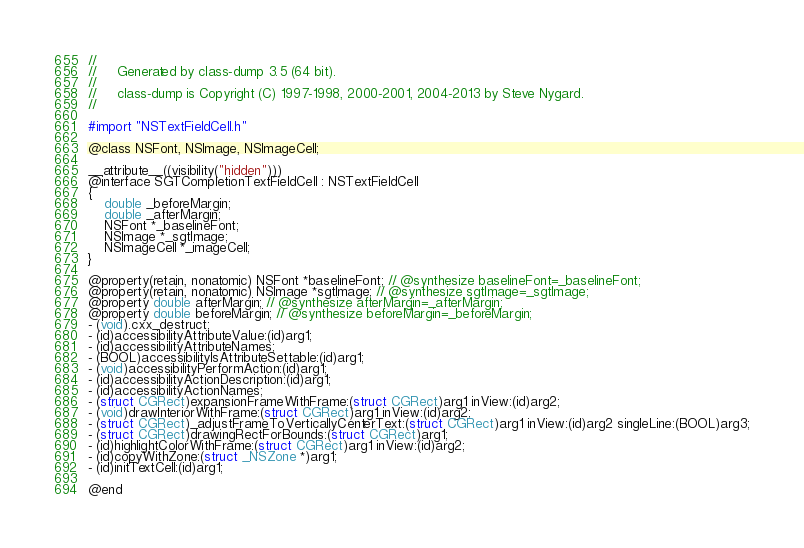<code> <loc_0><loc_0><loc_500><loc_500><_C_>//
//     Generated by class-dump 3.5 (64 bit).
//
//     class-dump is Copyright (C) 1997-1998, 2000-2001, 2004-2013 by Steve Nygard.
//

#import "NSTextFieldCell.h"

@class NSFont, NSImage, NSImageCell;

__attribute__((visibility("hidden")))
@interface SGTCompletionTextFieldCell : NSTextFieldCell
{
    double _beforeMargin;
    double _afterMargin;
    NSFont *_baselineFont;
    NSImage *_sgtImage;
    NSImageCell *_imageCell;
}

@property(retain, nonatomic) NSFont *baselineFont; // @synthesize baselineFont=_baselineFont;
@property(retain, nonatomic) NSImage *sgtImage; // @synthesize sgtImage=_sgtImage;
@property double afterMargin; // @synthesize afterMargin=_afterMargin;
@property double beforeMargin; // @synthesize beforeMargin=_beforeMargin;
- (void).cxx_destruct;
- (id)accessibilityAttributeValue:(id)arg1;
- (id)accessibilityAttributeNames;
- (BOOL)accessibilityIsAttributeSettable:(id)arg1;
- (void)accessibilityPerformAction:(id)arg1;
- (id)accessibilityActionDescription:(id)arg1;
- (id)accessibilityActionNames;
- (struct CGRect)expansionFrameWithFrame:(struct CGRect)arg1 inView:(id)arg2;
- (void)drawInteriorWithFrame:(struct CGRect)arg1 inView:(id)arg2;
- (struct CGRect)_adjustFrameToVerticallyCenterText:(struct CGRect)arg1 inView:(id)arg2 singleLine:(BOOL)arg3;
- (struct CGRect)drawingRectForBounds:(struct CGRect)arg1;
- (id)highlightColorWithFrame:(struct CGRect)arg1 inView:(id)arg2;
- (id)copyWithZone:(struct _NSZone *)arg1;
- (id)initTextCell:(id)arg1;

@end

</code> 